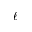<formula> <loc_0><loc_0><loc_500><loc_500>\ell</formula> 